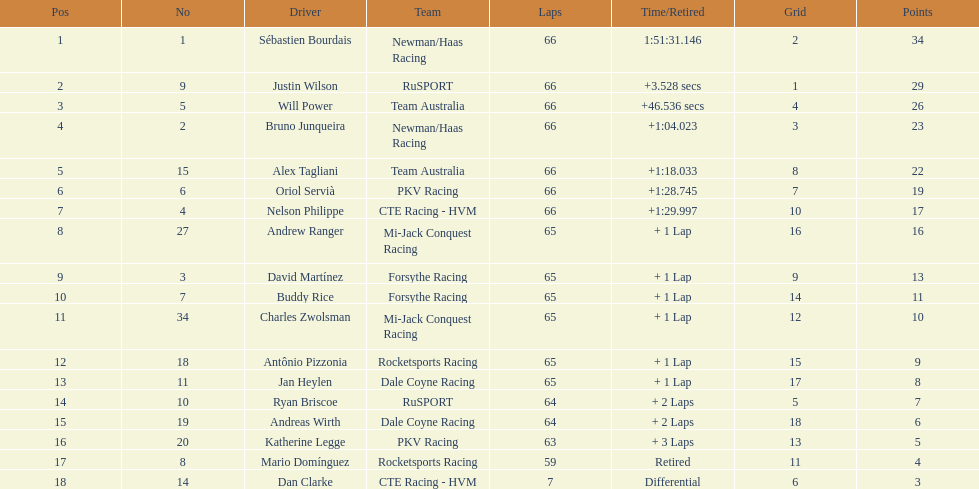Rice ranked 10th. who finished following? Charles Zwolsman. 